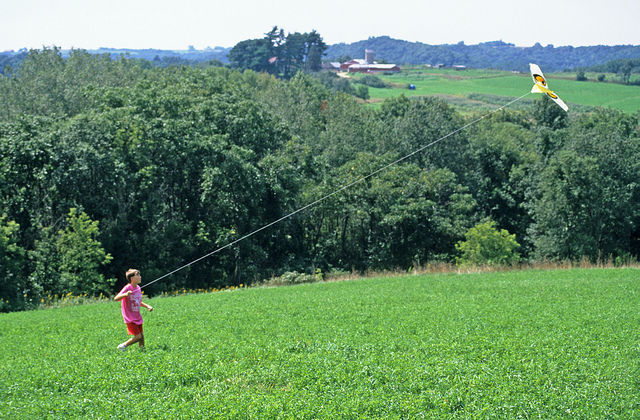How might the child's activity change if the weather was windy? If the weather was windy, the child's kite-flying experience could become even more exhilarating. The kite would catch the wind more easily, allowing it to soar higher and stay aloft with less effort. However, the child would need to be cautious of sudden strong gusts that could potentially cause the kite to dive or get entangled in the nearby trees. A windy day would heighten the excitement, but also require better skill and attentiveness. 